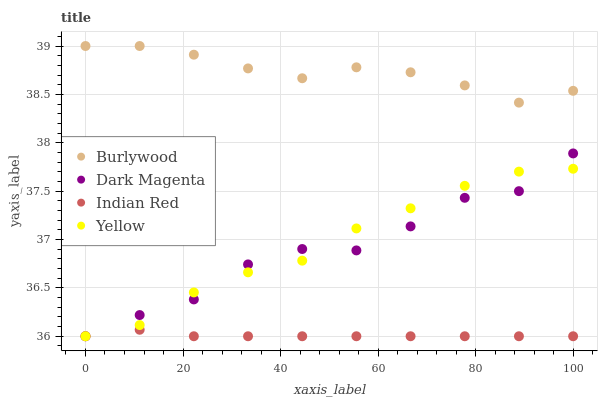Does Indian Red have the minimum area under the curve?
Answer yes or no. Yes. Does Burlywood have the maximum area under the curve?
Answer yes or no. Yes. Does Yellow have the minimum area under the curve?
Answer yes or no. No. Does Yellow have the maximum area under the curve?
Answer yes or no. No. Is Indian Red the smoothest?
Answer yes or no. Yes. Is Dark Magenta the roughest?
Answer yes or no. Yes. Is Yellow the smoothest?
Answer yes or no. No. Is Yellow the roughest?
Answer yes or no. No. Does Yellow have the lowest value?
Answer yes or no. Yes. Does Burlywood have the highest value?
Answer yes or no. Yes. Does Yellow have the highest value?
Answer yes or no. No. Is Yellow less than Burlywood?
Answer yes or no. Yes. Is Burlywood greater than Yellow?
Answer yes or no. Yes. Does Indian Red intersect Dark Magenta?
Answer yes or no. Yes. Is Indian Red less than Dark Magenta?
Answer yes or no. No. Is Indian Red greater than Dark Magenta?
Answer yes or no. No. Does Yellow intersect Burlywood?
Answer yes or no. No. 